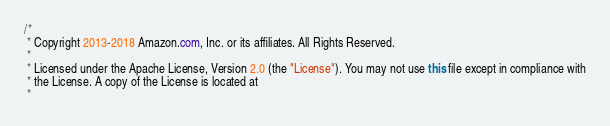<code> <loc_0><loc_0><loc_500><loc_500><_Java_>/*
 * Copyright 2013-2018 Amazon.com, Inc. or its affiliates. All Rights Reserved.
 * 
 * Licensed under the Apache License, Version 2.0 (the "License"). You may not use this file except in compliance with
 * the License. A copy of the License is located at
 * </code> 